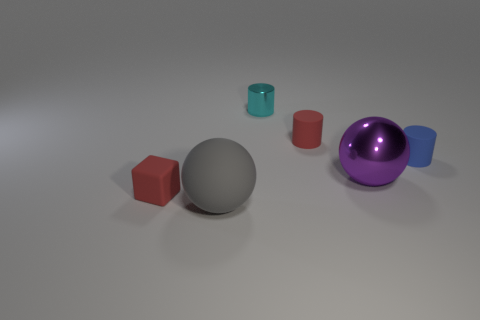Add 3 tiny red things. How many objects exist? 9 Subtract all spheres. How many objects are left? 4 Subtract all brown things. Subtract all metallic things. How many objects are left? 4 Add 1 tiny blue cylinders. How many tiny blue cylinders are left? 2 Add 6 shiny things. How many shiny things exist? 8 Subtract 0 yellow cubes. How many objects are left? 6 